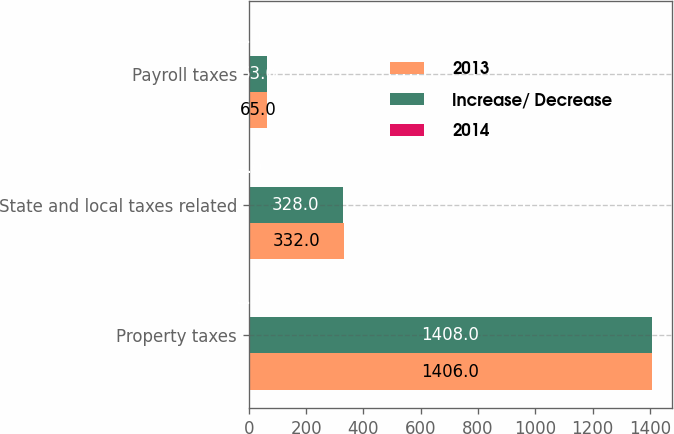<chart> <loc_0><loc_0><loc_500><loc_500><stacked_bar_chart><ecel><fcel>Property taxes<fcel>State and local taxes related<fcel>Payroll taxes<nl><fcel>2013<fcel>1406<fcel>332<fcel>65<nl><fcel>Increase/ Decrease<fcel>1408<fcel>328<fcel>63<nl><fcel>2014<fcel>2<fcel>4<fcel>2<nl></chart> 